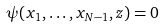Convert formula to latex. <formula><loc_0><loc_0><loc_500><loc_500>\psi ( x _ { 1 } , \dots , x _ { N - 1 } , z ) = 0</formula> 